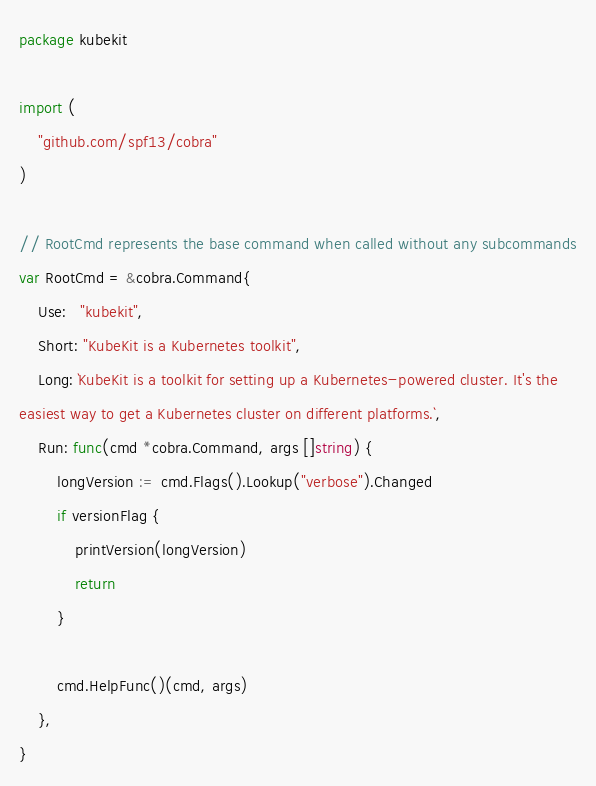<code> <loc_0><loc_0><loc_500><loc_500><_Go_>package kubekit

import (
	"github.com/spf13/cobra"
)

// RootCmd represents the base command when called without any subcommands
var RootCmd = &cobra.Command{
	Use:   "kubekit",
	Short: "KubeKit is a Kubernetes toolkit",
	Long: `KubeKit is a toolkit for setting up a Kubernetes-powered cluster. It's the
easiest way to get a Kubernetes cluster on different platforms.`,
	Run: func(cmd *cobra.Command, args []string) {
		longVersion := cmd.Flags().Lookup("verbose").Changed
		if versionFlag {
			printVersion(longVersion)
			return
		}

		cmd.HelpFunc()(cmd, args)
	},
}
</code> 